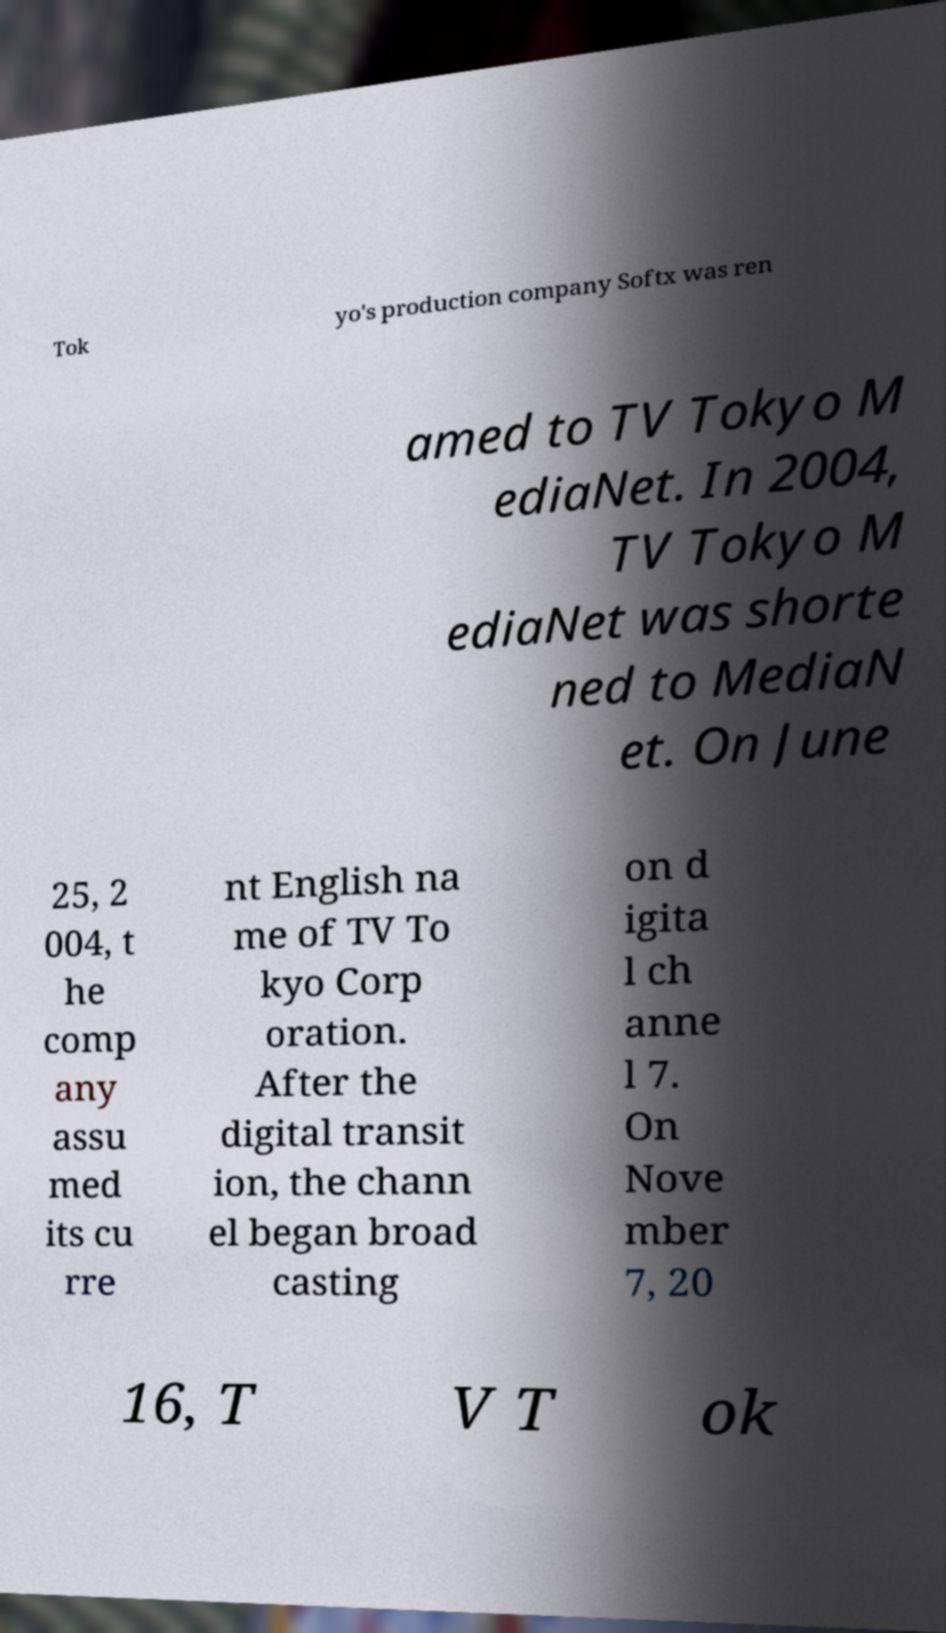There's text embedded in this image that I need extracted. Can you transcribe it verbatim? Tok yo's production company Softx was ren amed to TV Tokyo M ediaNet. In 2004, TV Tokyo M ediaNet was shorte ned to MediaN et. On June 25, 2 004, t he comp any assu med its cu rre nt English na me of TV To kyo Corp oration. After the digital transit ion, the chann el began broad casting on d igita l ch anne l 7. On Nove mber 7, 20 16, T V T ok 